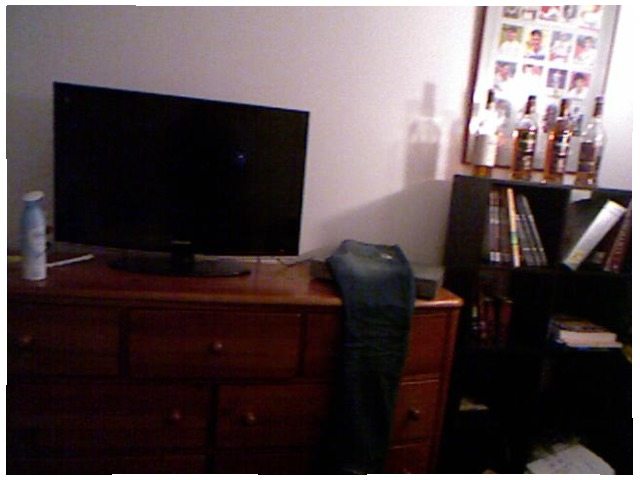<image>
Is there a tv on the dresser? Yes. Looking at the image, I can see the tv is positioned on top of the dresser, with the dresser providing support. Is the bottle on the table? No. The bottle is not positioned on the table. They may be near each other, but the bottle is not supported by or resting on top of the table. 